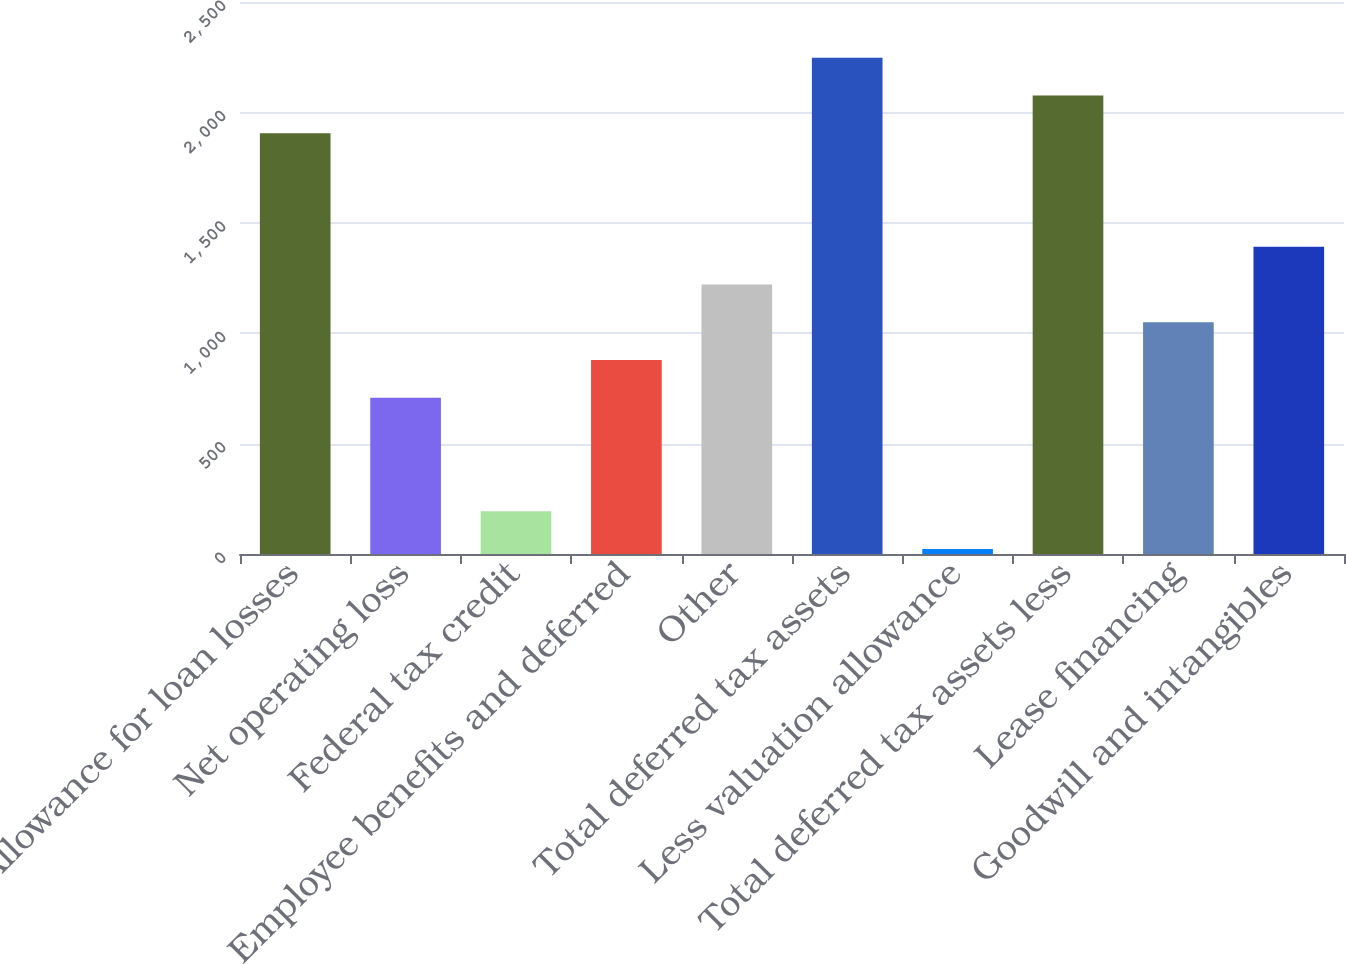<chart> <loc_0><loc_0><loc_500><loc_500><bar_chart><fcel>Allowance for loan losses<fcel>Net operating loss<fcel>Federal tax credit<fcel>Employee benefits and deferred<fcel>Other<fcel>Total deferred tax assets<fcel>Less valuation allowance<fcel>Total deferred tax assets less<fcel>Lease financing<fcel>Goodwill and intangibles<nl><fcel>1905.1<fcel>707.4<fcel>194.1<fcel>878.5<fcel>1220.7<fcel>2247.3<fcel>23<fcel>2076.2<fcel>1049.6<fcel>1391.8<nl></chart> 